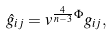Convert formula to latex. <formula><loc_0><loc_0><loc_500><loc_500>\hat { g } _ { i j } = v ^ { \frac { 4 } { n - 3 } \Phi } g _ { i j } ,</formula> 